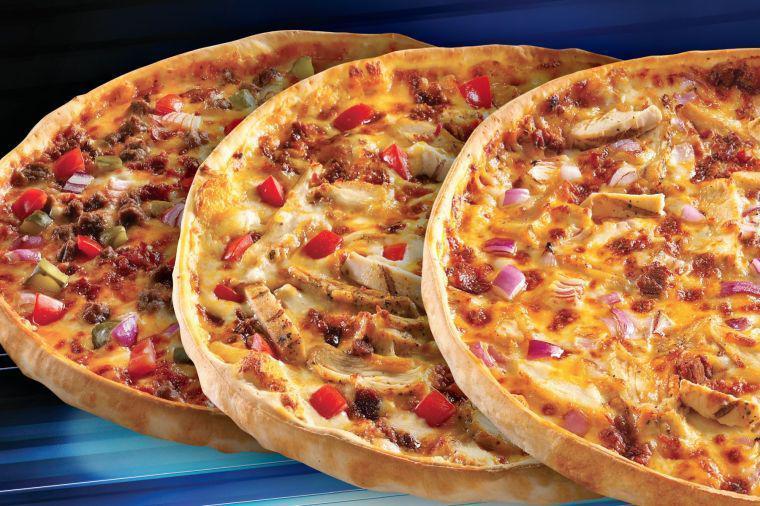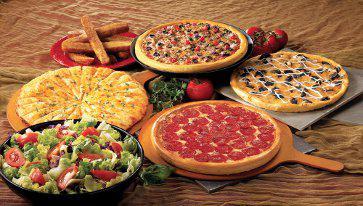The first image is the image on the left, the second image is the image on the right. Evaluate the accuracy of this statement regarding the images: "One image shows one sliced pepperoni pizza with all the slices still lying flat, and the other image shows a pepperoni pizza with a slice that is out of place and off the surface.". Is it true? Answer yes or no. No. The first image is the image on the left, the second image is the image on the right. Considering the images on both sides, is "All pizzas pictured are whole without any pieces missing or removed." valid? Answer yes or no. Yes. 